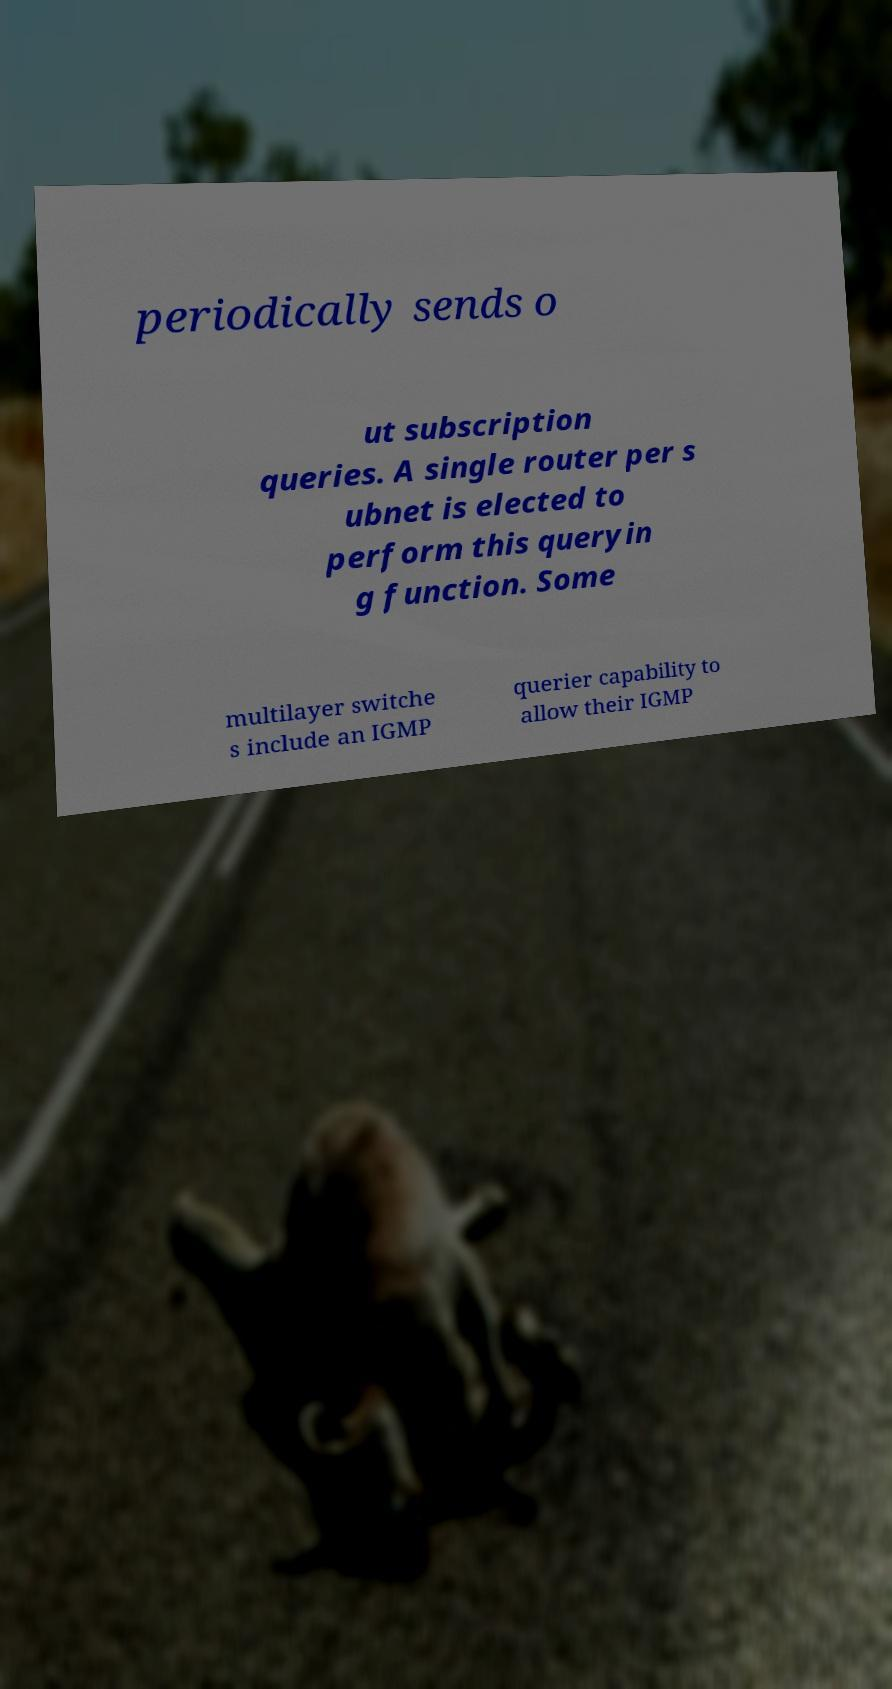Please identify and transcribe the text found in this image. periodically sends o ut subscription queries. A single router per s ubnet is elected to perform this queryin g function. Some multilayer switche s include an IGMP querier capability to allow their IGMP 